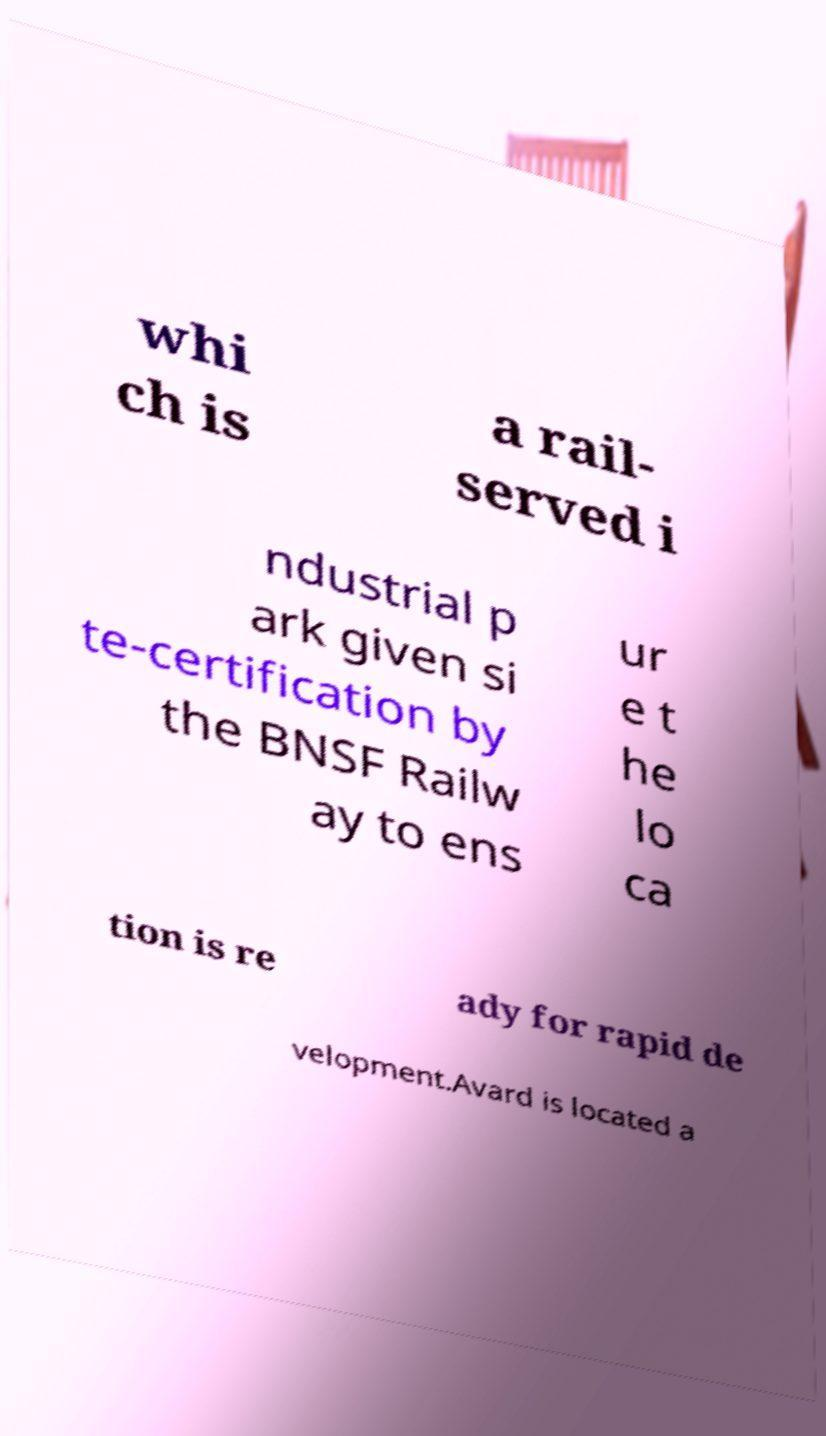Please identify and transcribe the text found in this image. whi ch is a rail- served i ndustrial p ark given si te-certification by the BNSF Railw ay to ens ur e t he lo ca tion is re ady for rapid de velopment.Avard is located a 